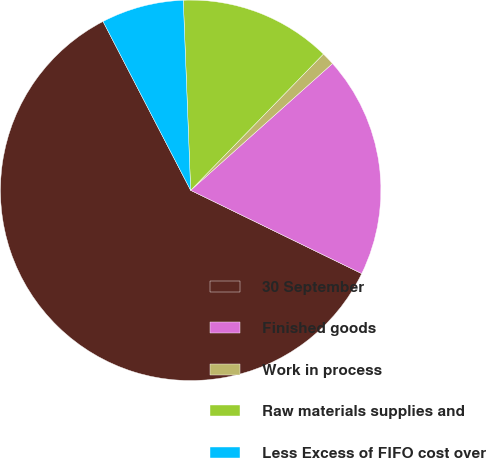Convert chart to OTSL. <chart><loc_0><loc_0><loc_500><loc_500><pie_chart><fcel>30 September<fcel>Finished goods<fcel>Work in process<fcel>Raw materials supplies and<fcel>Less Excess of FIFO cost over<nl><fcel>60.17%<fcel>18.82%<fcel>1.1%<fcel>12.91%<fcel>7.0%<nl></chart> 